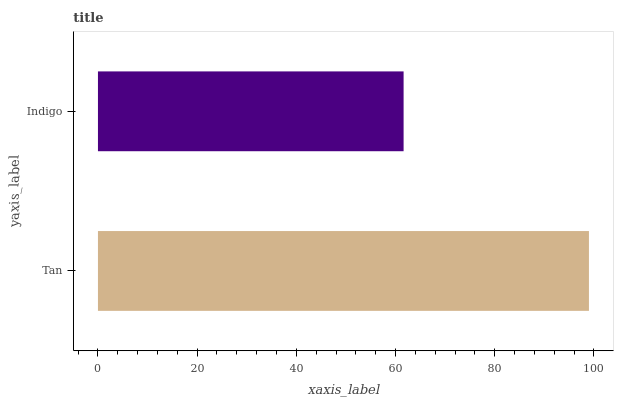Is Indigo the minimum?
Answer yes or no. Yes. Is Tan the maximum?
Answer yes or no. Yes. Is Indigo the maximum?
Answer yes or no. No. Is Tan greater than Indigo?
Answer yes or no. Yes. Is Indigo less than Tan?
Answer yes or no. Yes. Is Indigo greater than Tan?
Answer yes or no. No. Is Tan less than Indigo?
Answer yes or no. No. Is Tan the high median?
Answer yes or no. Yes. Is Indigo the low median?
Answer yes or no. Yes. Is Indigo the high median?
Answer yes or no. No. Is Tan the low median?
Answer yes or no. No. 